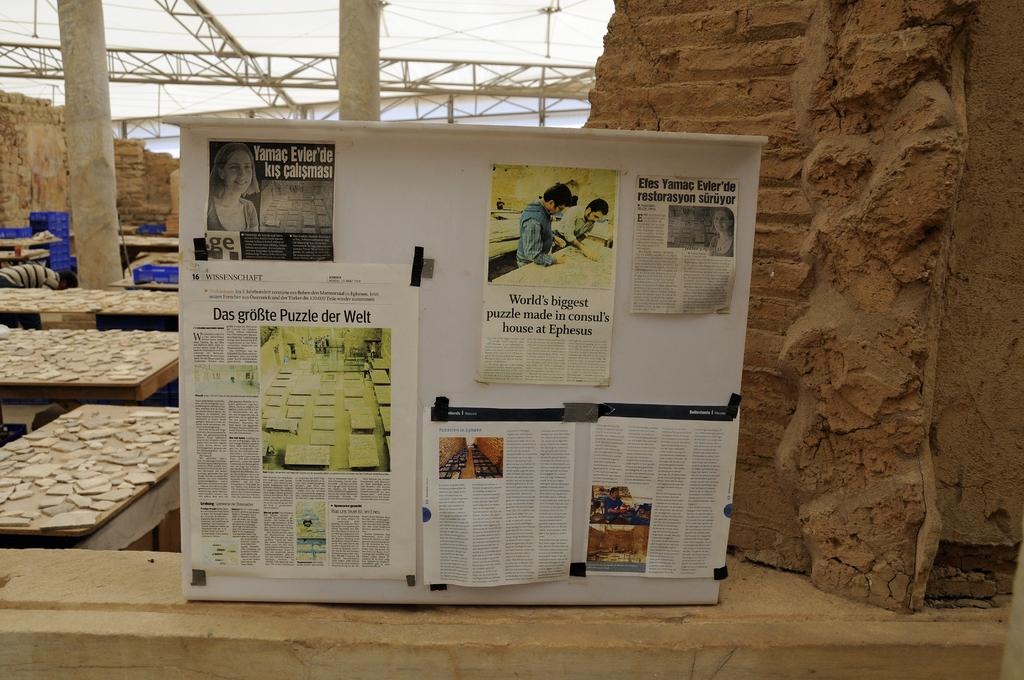<image>
Summarize the visual content of the image. Large poster showing different papers including one that says "World's biggest puzzle". 